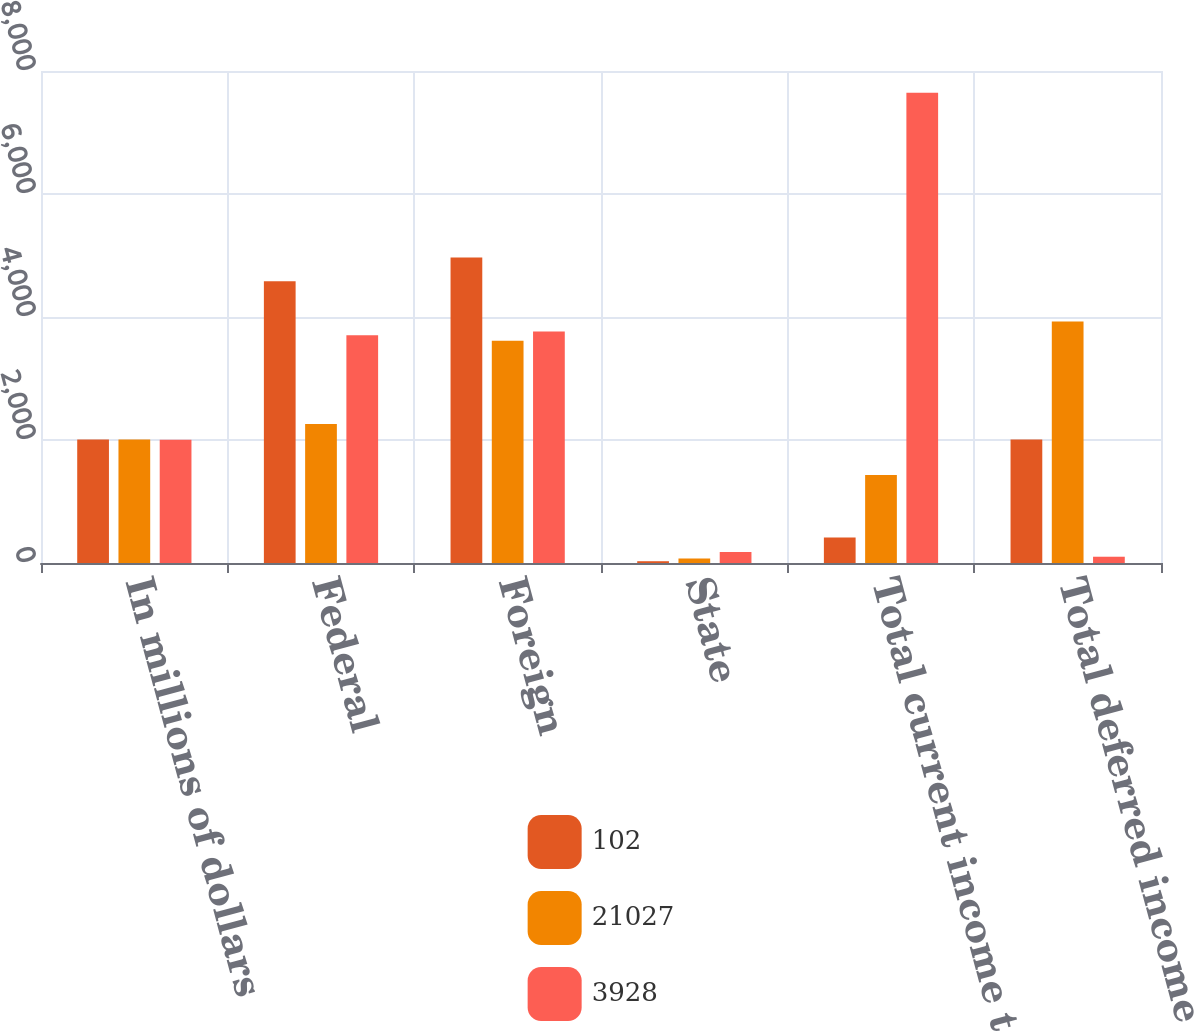Convert chart. <chart><loc_0><loc_0><loc_500><loc_500><stacked_bar_chart><ecel><fcel>In millions of dollars<fcel>Federal<fcel>Foreign<fcel>State<fcel>Total current income taxes<fcel>Total deferred income taxes<nl><fcel>102<fcel>2008<fcel>4582<fcel>4968<fcel>29<fcel>415<fcel>2008<nl><fcel>21027<fcel>2007<fcel>2260<fcel>3615<fcel>75<fcel>1430<fcel>3928<nl><fcel>3928<fcel>2006<fcel>3703<fcel>3766<fcel>178<fcel>7647<fcel>102<nl></chart> 